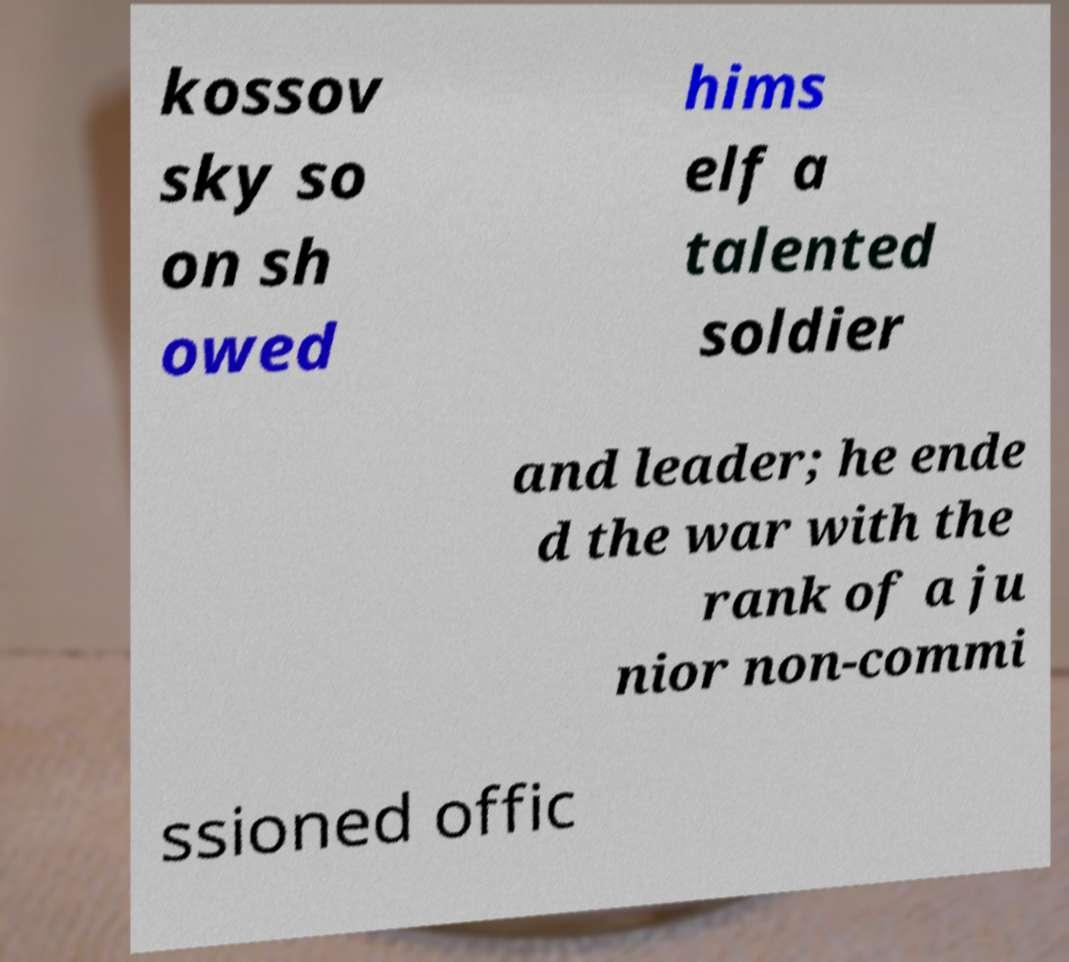I need the written content from this picture converted into text. Can you do that? kossov sky so on sh owed hims elf a talented soldier and leader; he ende d the war with the rank of a ju nior non-commi ssioned offic 